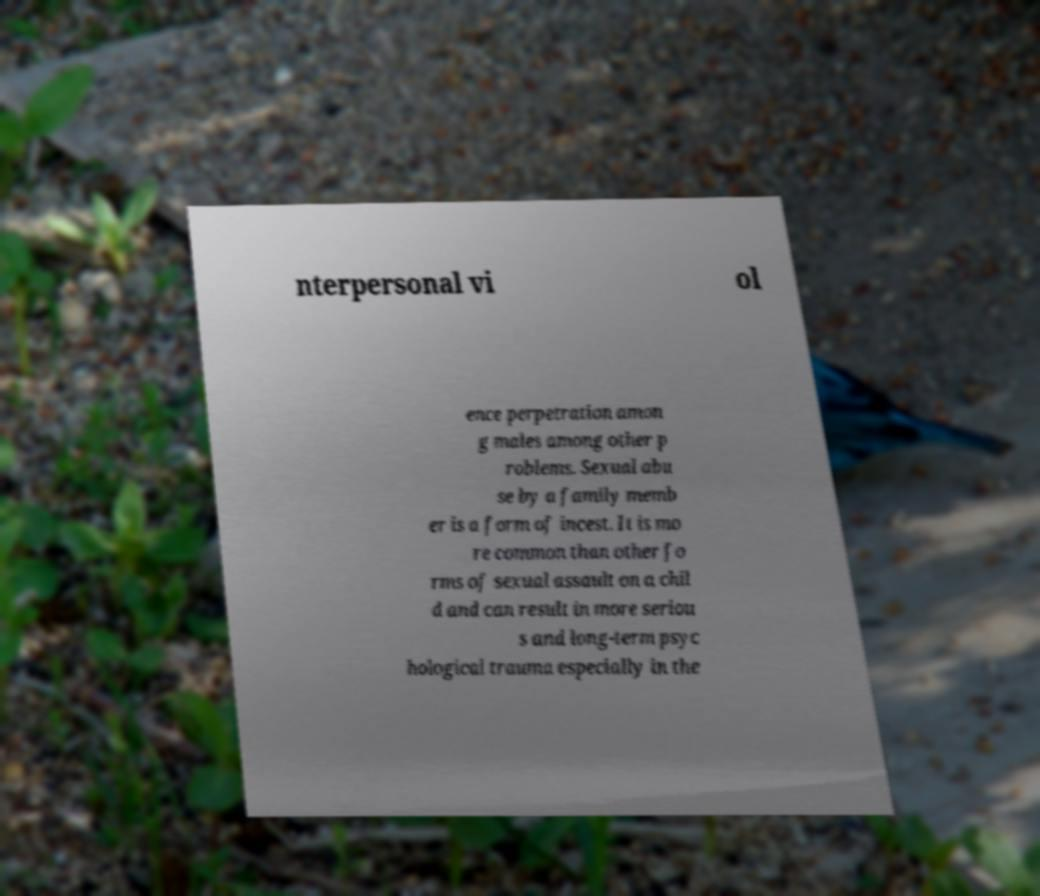Could you extract and type out the text from this image? nterpersonal vi ol ence perpetration amon g males among other p roblems. Sexual abu se by a family memb er is a form of incest. It is mo re common than other fo rms of sexual assault on a chil d and can result in more seriou s and long-term psyc hological trauma especially in the 